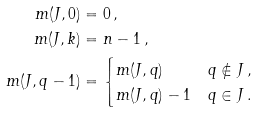Convert formula to latex. <formula><loc_0><loc_0><loc_500><loc_500>m ( J , 0 ) & = 0 \, , \\ m ( J , k ) & = n - 1 \, , \\ m ( J , q - 1 ) & = \begin{cases} m ( J , q ) & q \not \in J \, , \\ m ( J , q ) - 1 & q \in J \, . \end{cases}</formula> 